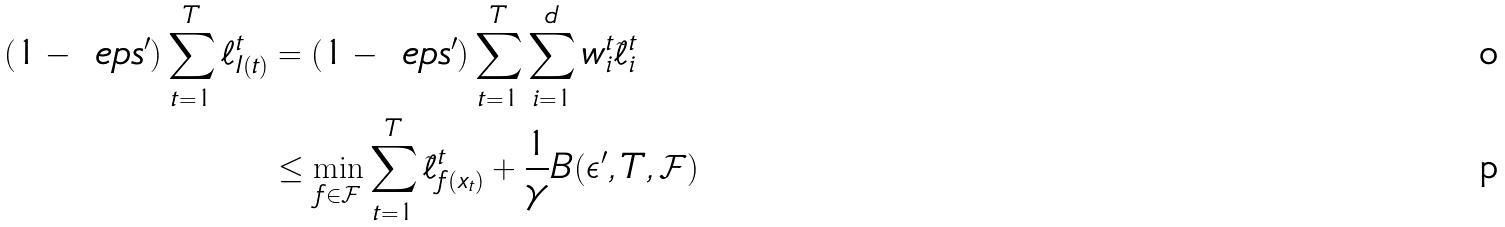Convert formula to latex. <formula><loc_0><loc_0><loc_500><loc_500>( 1 - \ e p s ^ { \prime } ) \sum _ { t = 1 } ^ { T } \ell ^ { t } _ { I ( t ) } & = ( 1 - \ e p s ^ { \prime } ) \sum _ { t = 1 } ^ { T } \sum _ { i = 1 } ^ { d } w ^ { t } _ { i } \tilde { \ell } ^ { t } _ { i } \\ & \leq \min _ { f \in \mathcal { F } } \sum _ { t = 1 } ^ { T } \tilde { \ell } ^ { t } _ { f ( x _ { t } ) } + \frac { 1 } { \gamma } B ( \epsilon ^ { \prime } , T , \mathcal { F } )</formula> 